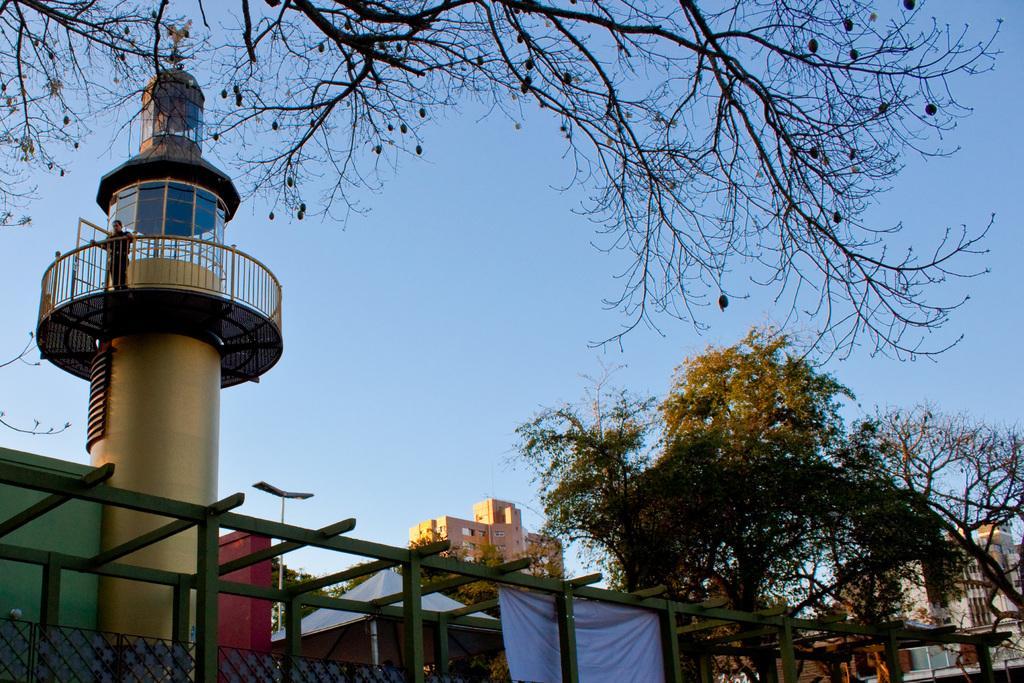How would you summarize this image in a sentence or two? In the image we can see there are buildings and trees. Here we can see watching tower and there is a person standing, wearing clothes. Here we can see the fence, pole, banner and the pale blue sky. 